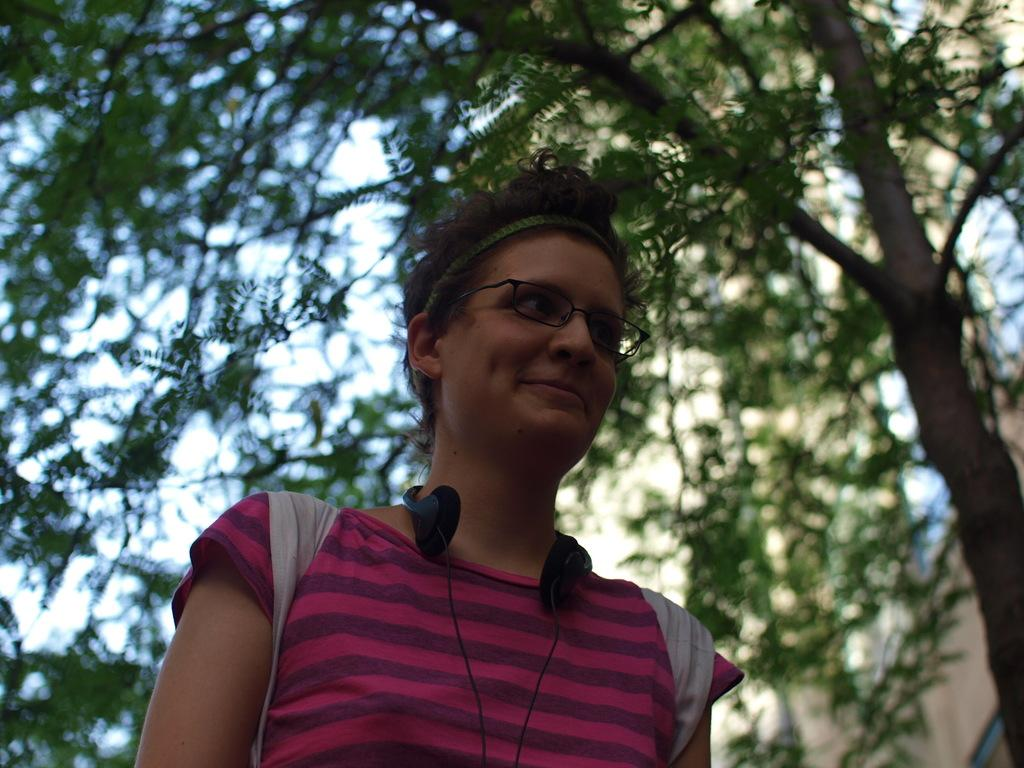What can be seen in the image? There is a person in the image. Can you describe the person's appearance? The person is wearing spectacles and headphones. What is visible in the background of the image? There are trees and the sky in the background of the image. What type of hammer is the robin using in the image? There is no robin or hammer present in the image. 